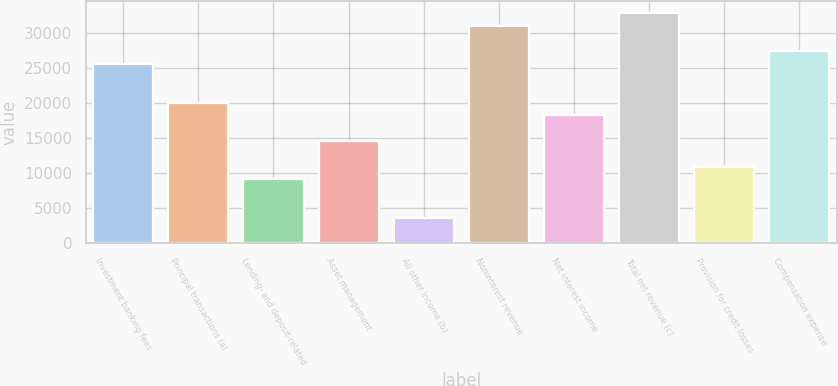Convert chart. <chart><loc_0><loc_0><loc_500><loc_500><bar_chart><fcel>Investment banking fees<fcel>Principal transactions (a)<fcel>Lending- and deposit-related<fcel>Asset management<fcel>All other income (b)<fcel>Noninterest revenue<fcel>Net interest income<fcel>Total net revenue (c)<fcel>Provision for credit losses<fcel>Compensation expense<nl><fcel>25607.2<fcel>20120.1<fcel>9145.74<fcel>14632.9<fcel>3658.57<fcel>31094.4<fcel>18291<fcel>32923.5<fcel>10974.8<fcel>27436.3<nl></chart> 